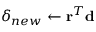Convert formula to latex. <formula><loc_0><loc_0><loc_500><loc_500>\delta _ { n e w } \leftarrow r ^ { T } d</formula> 